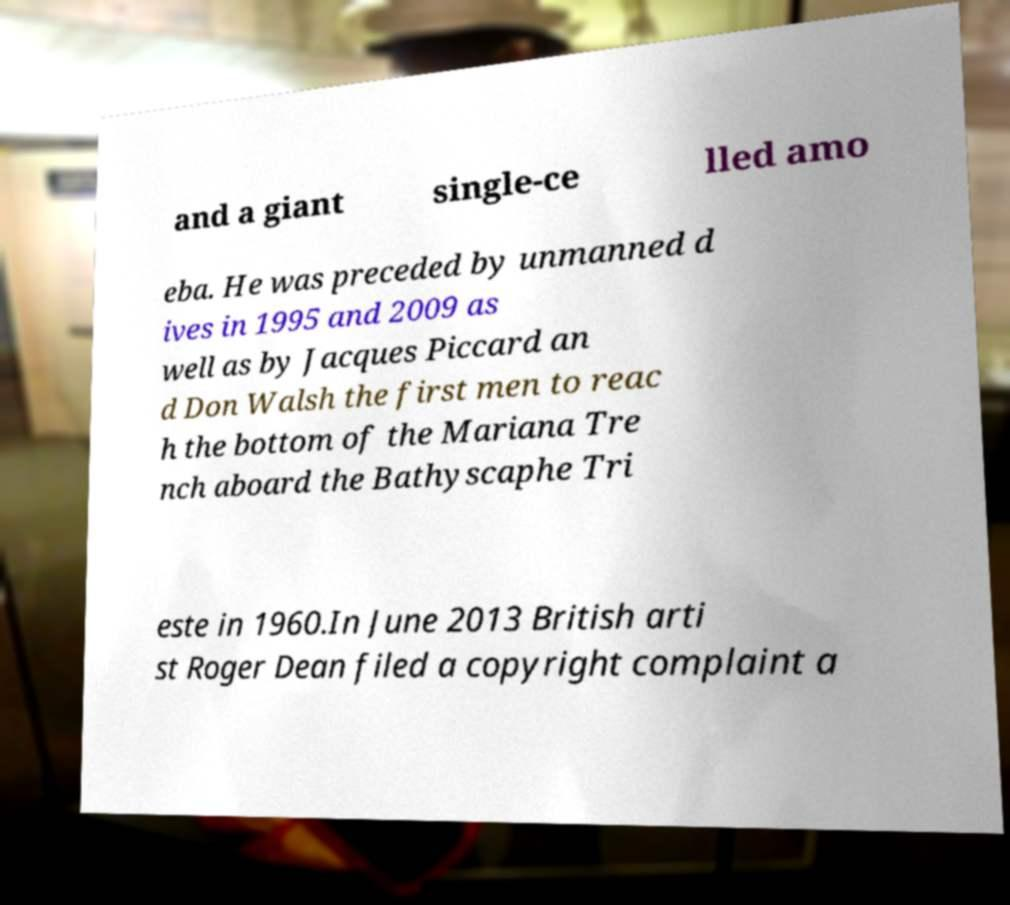What messages or text are displayed in this image? I need them in a readable, typed format. and a giant single-ce lled amo eba. He was preceded by unmanned d ives in 1995 and 2009 as well as by Jacques Piccard an d Don Walsh the first men to reac h the bottom of the Mariana Tre nch aboard the Bathyscaphe Tri este in 1960.In June 2013 British arti st Roger Dean filed a copyright complaint a 